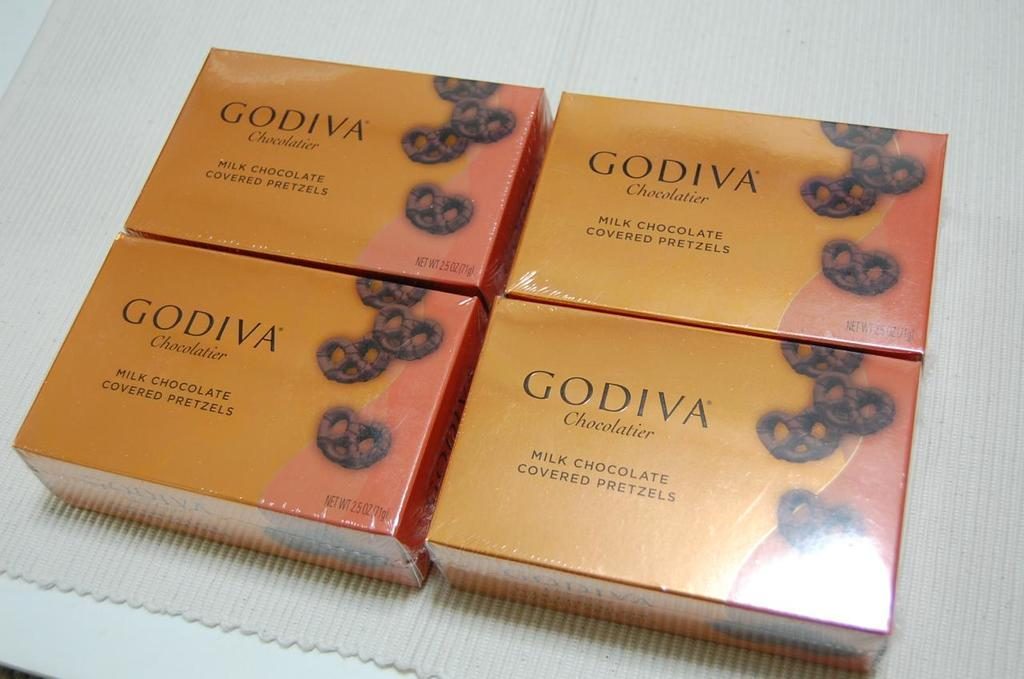<image>
Present a compact description of the photo's key features. Four Godiva boxes of chocolate sat on top of the table 